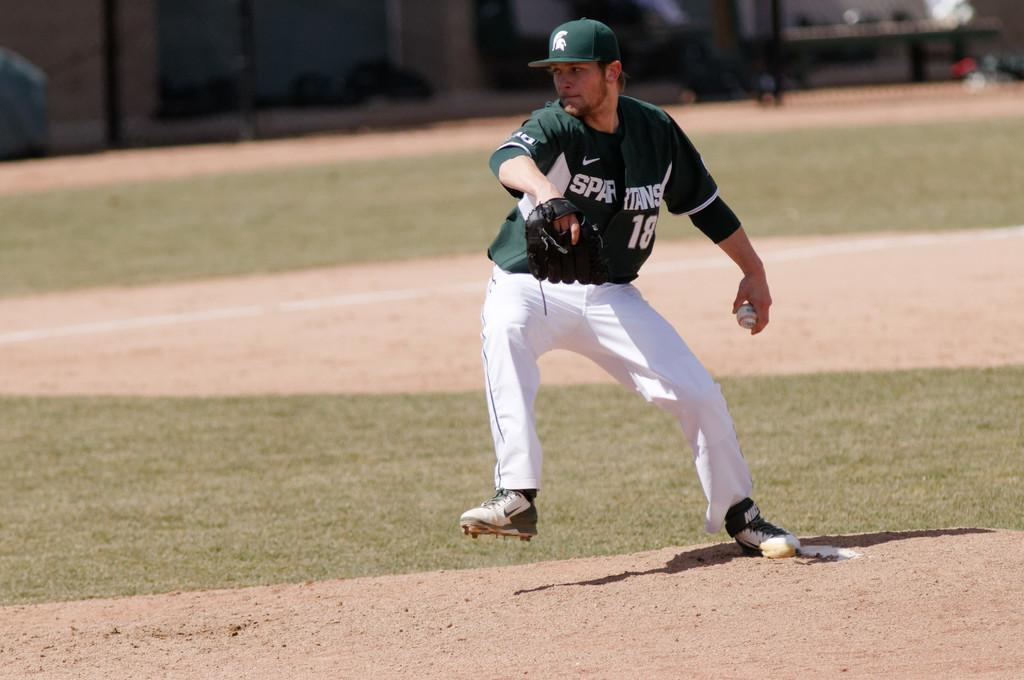<image>
Relay a brief, clear account of the picture shown. Number 18 of the Spartans right in the middle of a pitch 